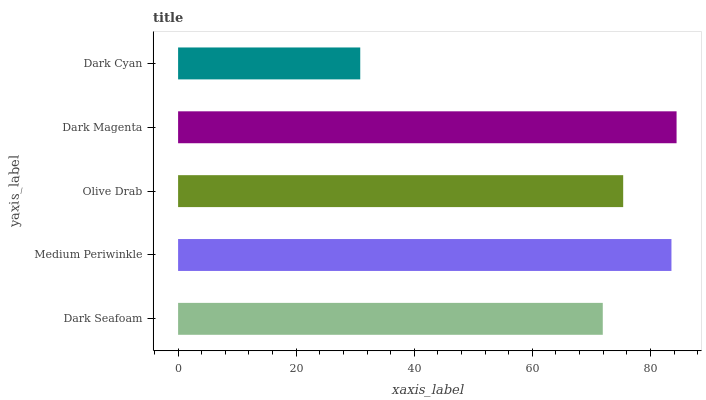Is Dark Cyan the minimum?
Answer yes or no. Yes. Is Dark Magenta the maximum?
Answer yes or no. Yes. Is Medium Periwinkle the minimum?
Answer yes or no. No. Is Medium Periwinkle the maximum?
Answer yes or no. No. Is Medium Periwinkle greater than Dark Seafoam?
Answer yes or no. Yes. Is Dark Seafoam less than Medium Periwinkle?
Answer yes or no. Yes. Is Dark Seafoam greater than Medium Periwinkle?
Answer yes or no. No. Is Medium Periwinkle less than Dark Seafoam?
Answer yes or no. No. Is Olive Drab the high median?
Answer yes or no. Yes. Is Olive Drab the low median?
Answer yes or no. Yes. Is Dark Cyan the high median?
Answer yes or no. No. Is Dark Cyan the low median?
Answer yes or no. No. 